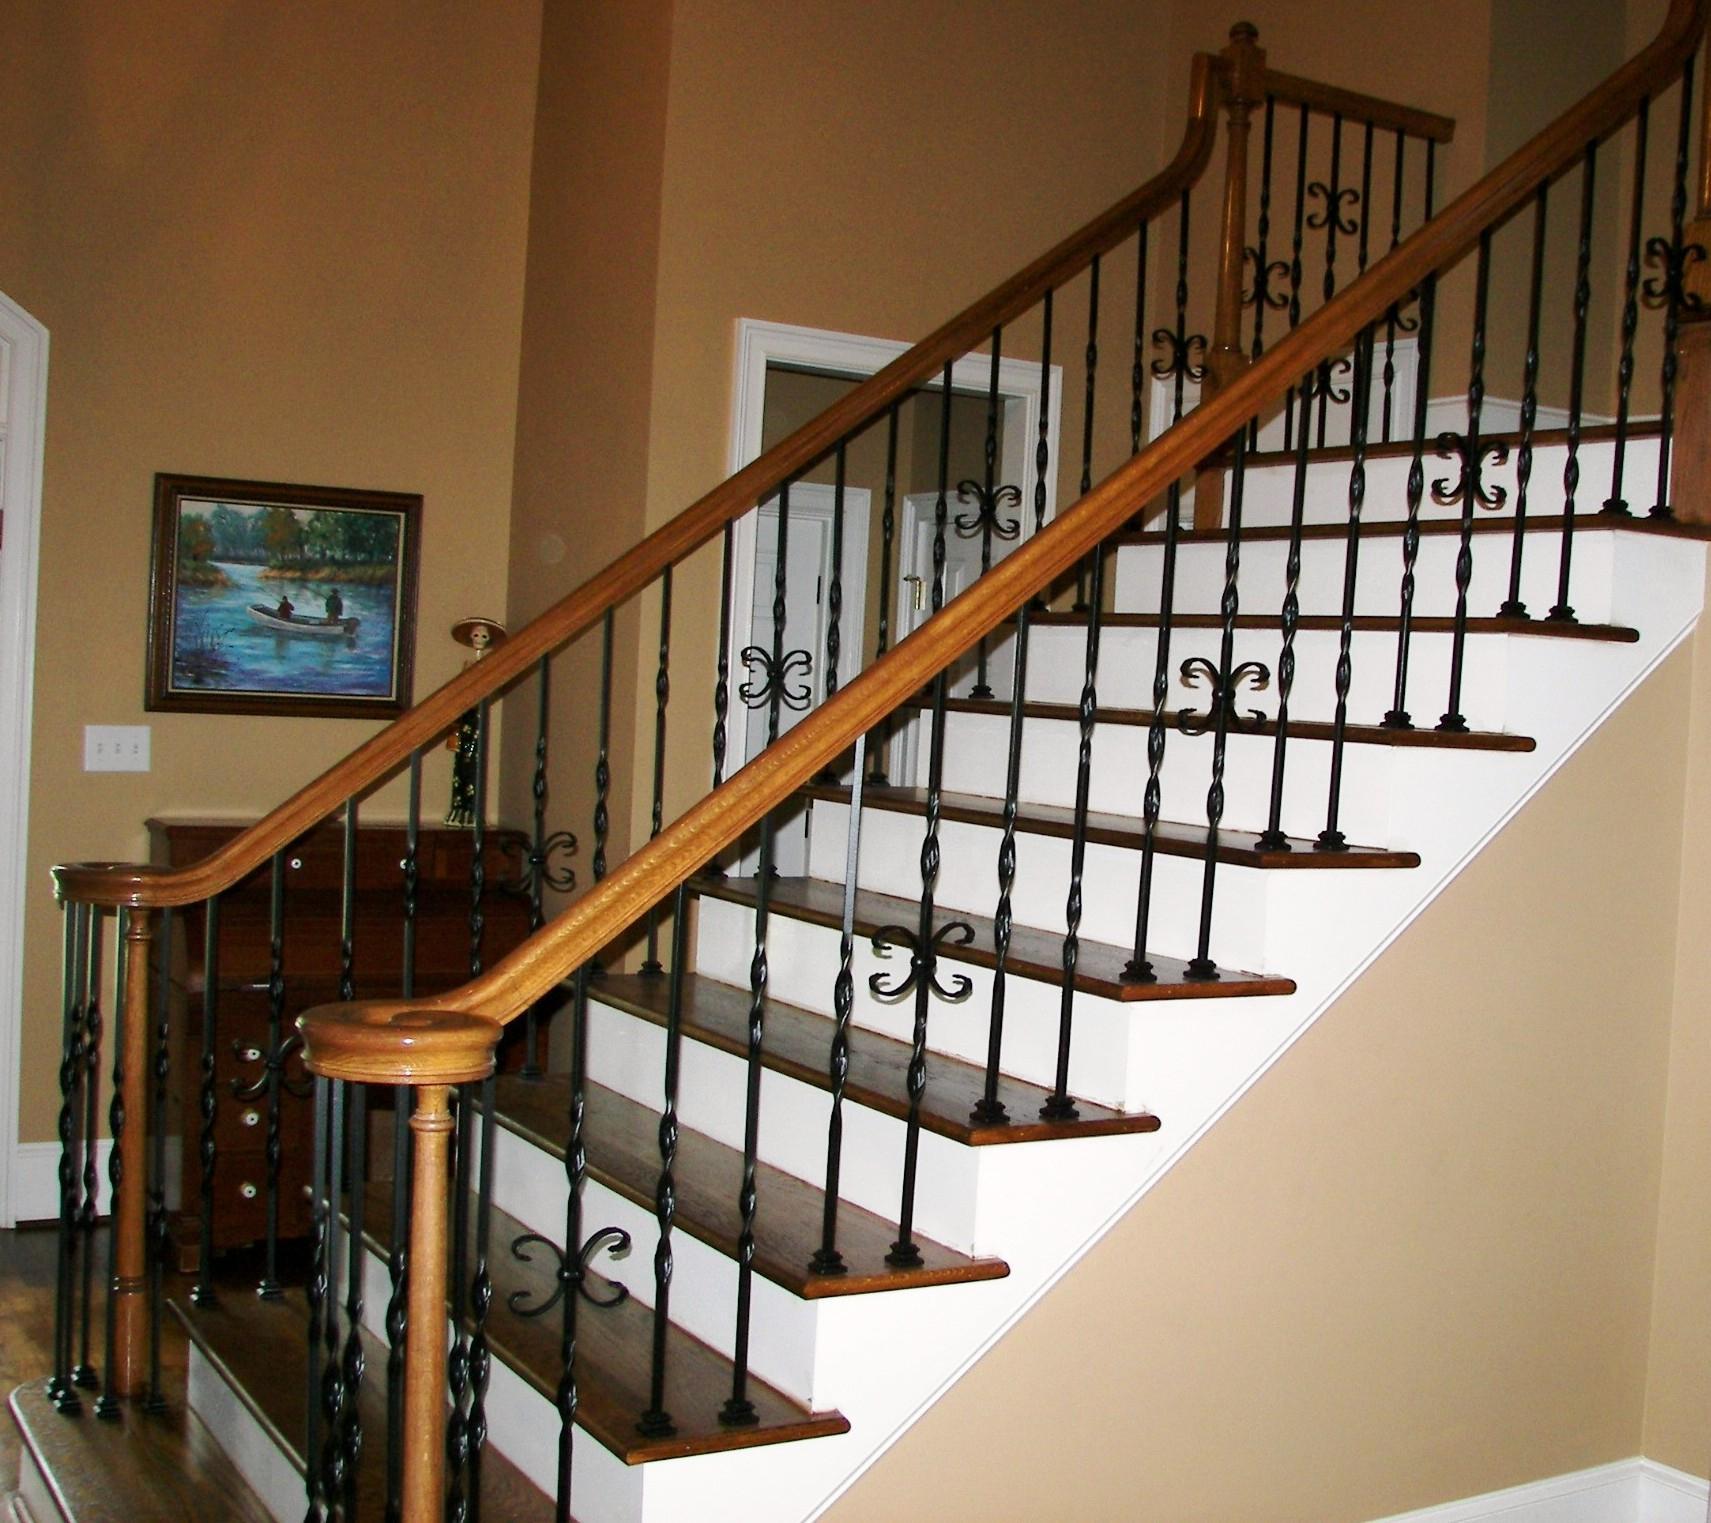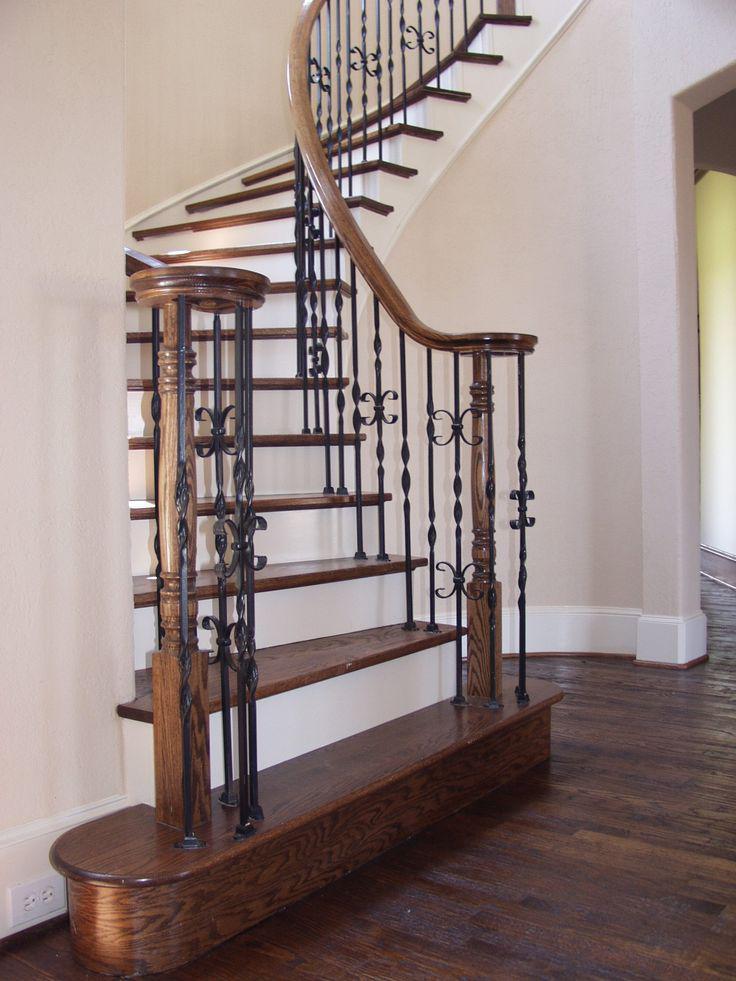The first image is the image on the left, the second image is the image on the right. Examine the images to the left and right. Is the description "The left staircase is straight and the right staircase is curved." accurate? Answer yes or no. Yes. The first image is the image on the left, the second image is the image on the right. Given the left and right images, does the statement "One of the images shows a straight staircase and the other shows a curved staircase." hold true? Answer yes or no. Yes. 